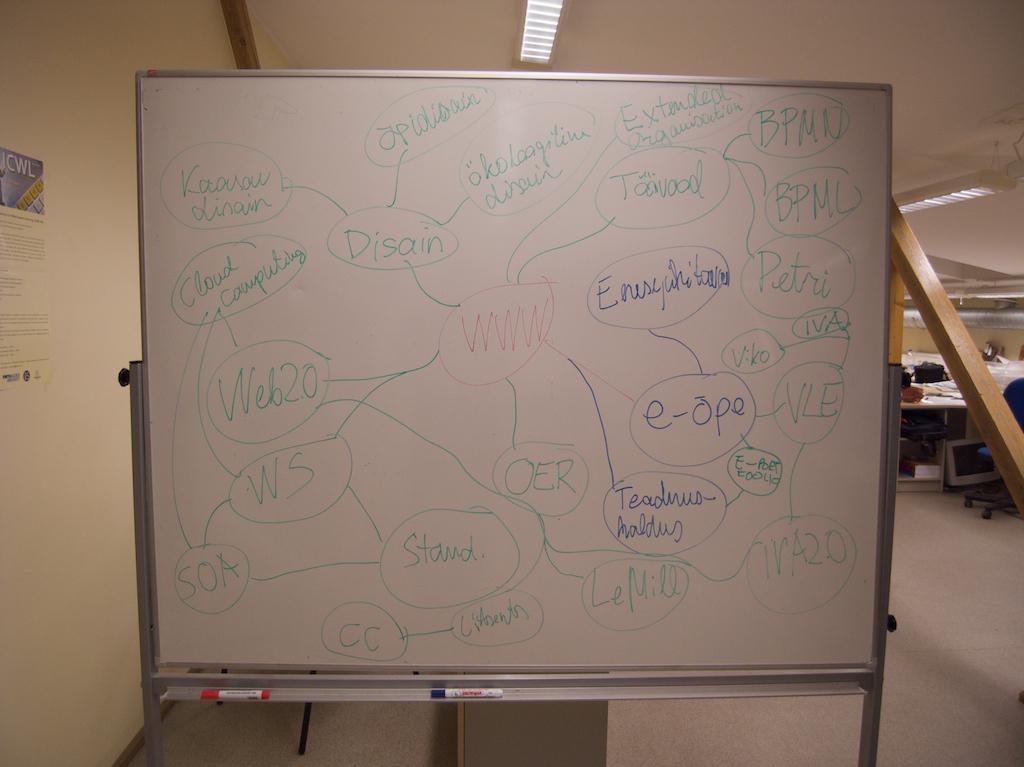Is this about chemistry?
Your response must be concise. No. 